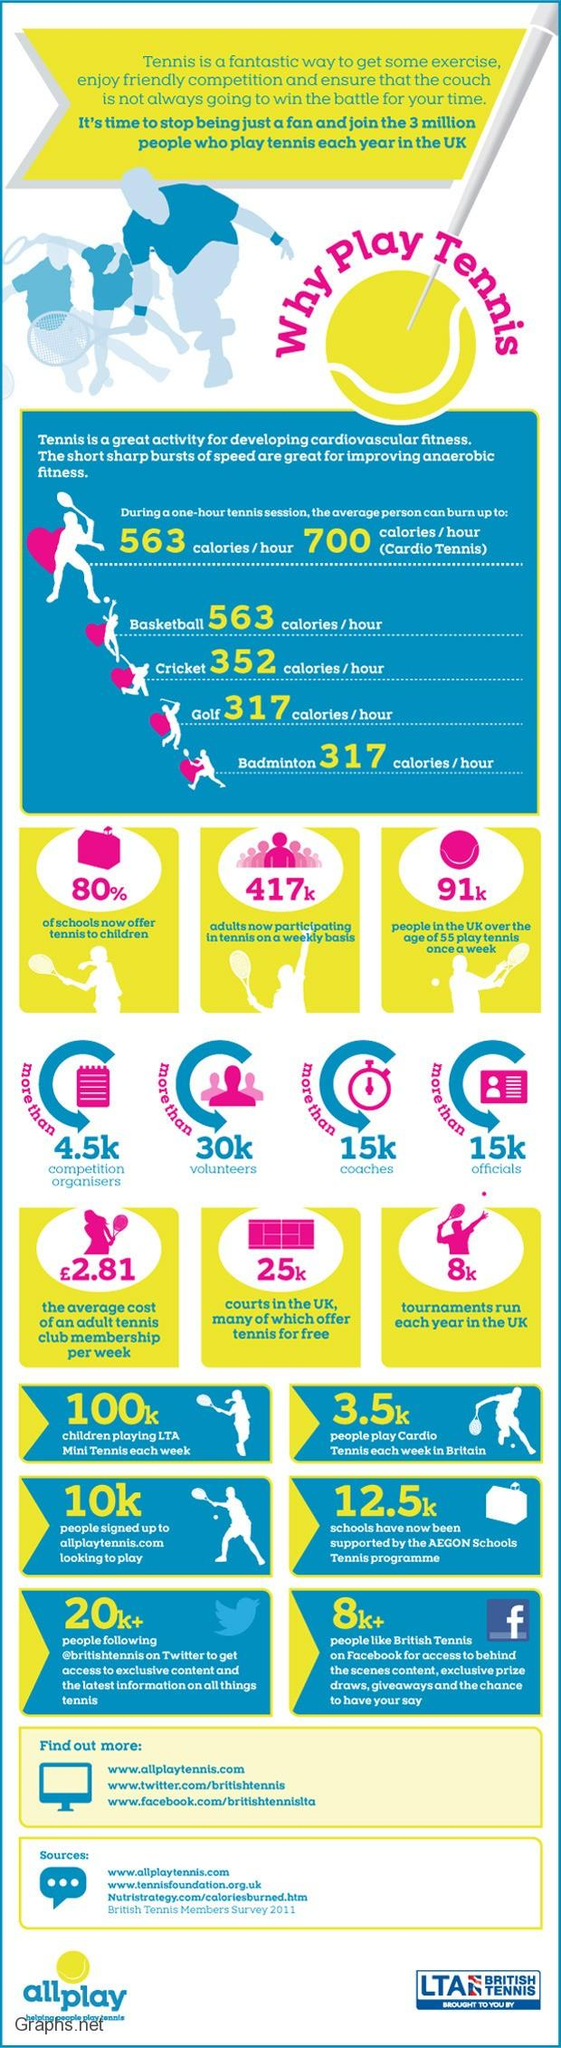Indicate a few pertinent items in this graphic. According to recent data, approximately 417,000 adults are participating in tennis on a weekly basis. Approximately 20% of schools are not offering tennis to children, according to recent data. It is estimated that approximately 3,500 individuals in Britain participate in cardio tennis on a weekly basis. Allplaytennis.com reports that approximately 10,000 people have signed up for their website. 